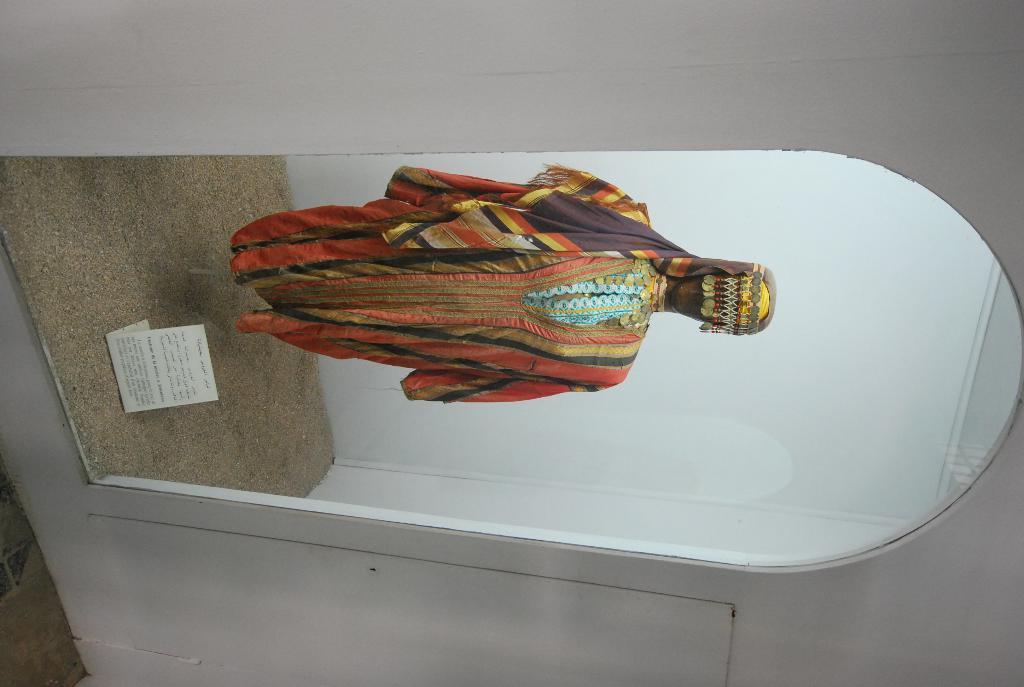Describe this image in one or two sentences. In this picture we can describe about the colorful cloth dress on the statue is placed in the mirror box. In front bottom side we can see some sand and paper brochure. 